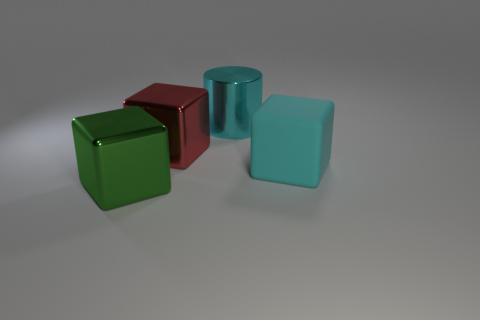What colors are represented in the objects seen in the image? The image features objects in three distinct colors: a vivid green, a deep red, and a soft cyan. Each color adds a unique visual element to the composition. 